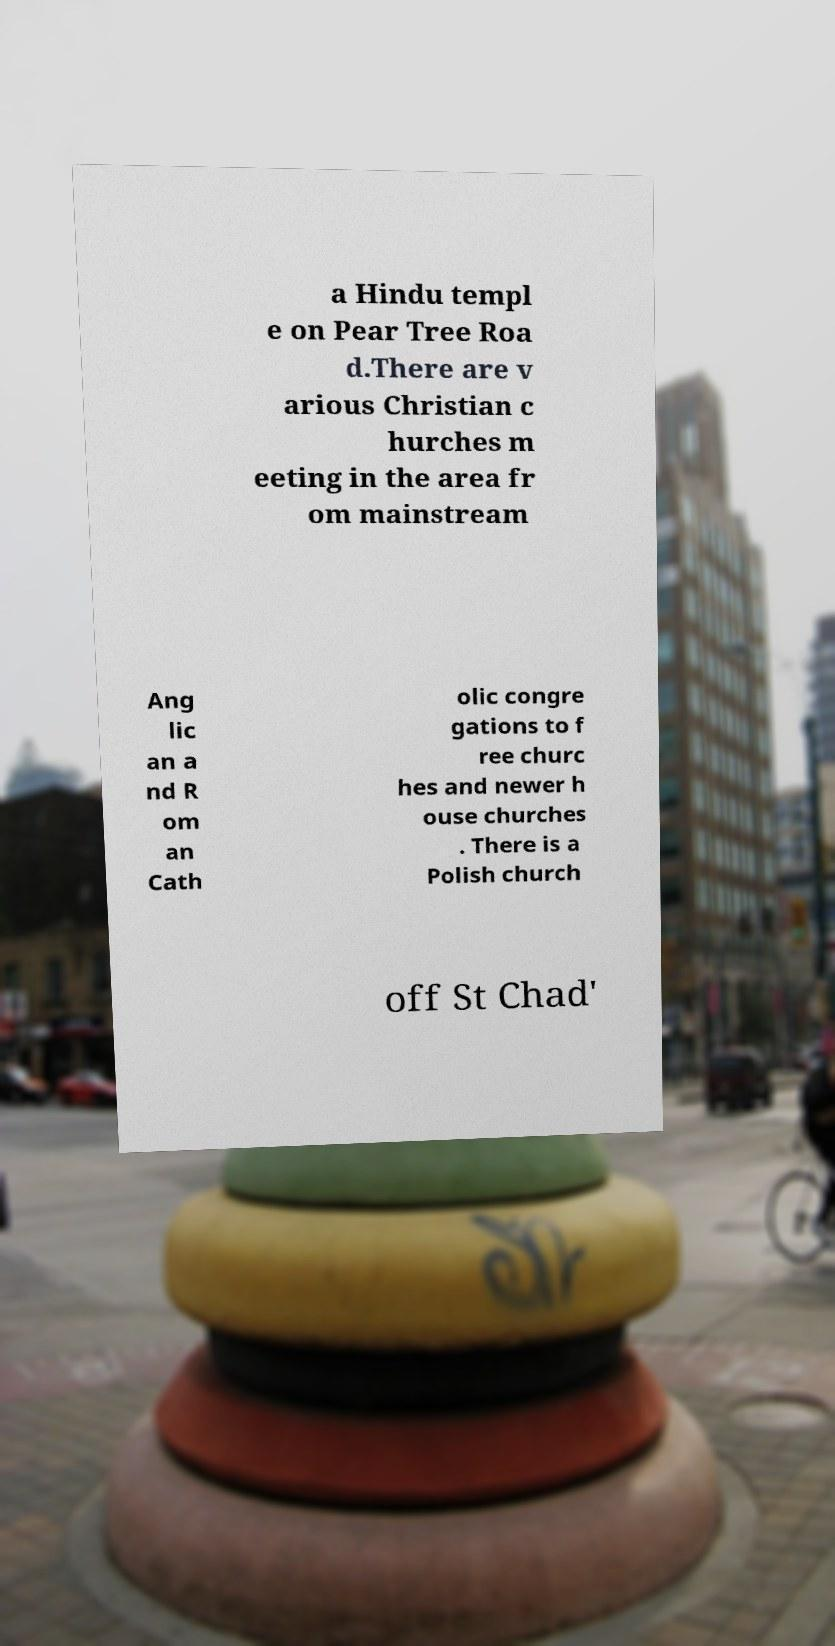There's text embedded in this image that I need extracted. Can you transcribe it verbatim? a Hindu templ e on Pear Tree Roa d.There are v arious Christian c hurches m eeting in the area fr om mainstream Ang lic an a nd R om an Cath olic congre gations to f ree churc hes and newer h ouse churches . There is a Polish church off St Chad' 